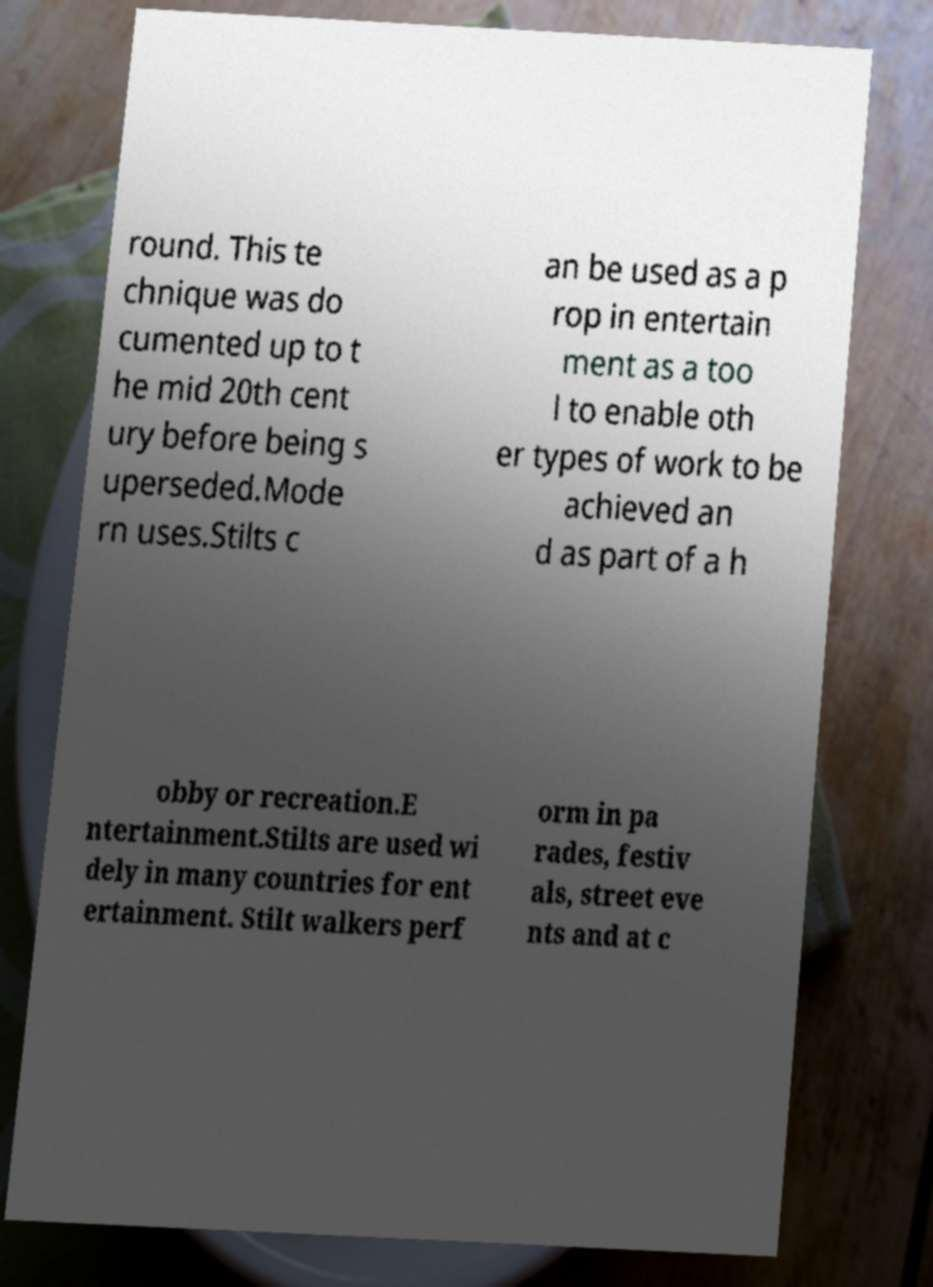Can you read and provide the text displayed in the image?This photo seems to have some interesting text. Can you extract and type it out for me? round. This te chnique was do cumented up to t he mid 20th cent ury before being s uperseded.Mode rn uses.Stilts c an be used as a p rop in entertain ment as a too l to enable oth er types of work to be achieved an d as part of a h obby or recreation.E ntertainment.Stilts are used wi dely in many countries for ent ertainment. Stilt walkers perf orm in pa rades, festiv als, street eve nts and at c 